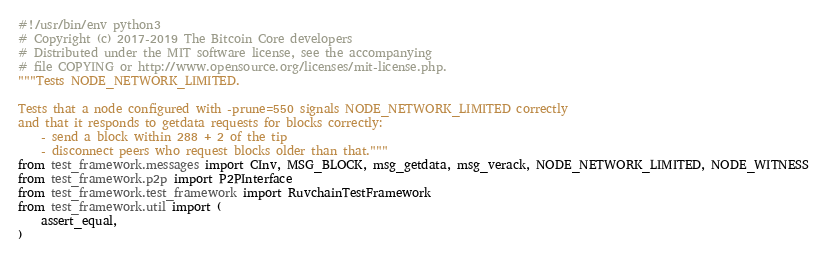Convert code to text. <code><loc_0><loc_0><loc_500><loc_500><_Python_>#!/usr/bin/env python3
# Copyright (c) 2017-2019 The Bitcoin Core developers
# Distributed under the MIT software license, see the accompanying
# file COPYING or http://www.opensource.org/licenses/mit-license.php.
"""Tests NODE_NETWORK_LIMITED.

Tests that a node configured with -prune=550 signals NODE_NETWORK_LIMITED correctly
and that it responds to getdata requests for blocks correctly:
    - send a block within 288 + 2 of the tip
    - disconnect peers who request blocks older than that."""
from test_framework.messages import CInv, MSG_BLOCK, msg_getdata, msg_verack, NODE_NETWORK_LIMITED, NODE_WITNESS
from test_framework.p2p import P2PInterface
from test_framework.test_framework import RuvchainTestFramework
from test_framework.util import (
    assert_equal,
)

</code> 